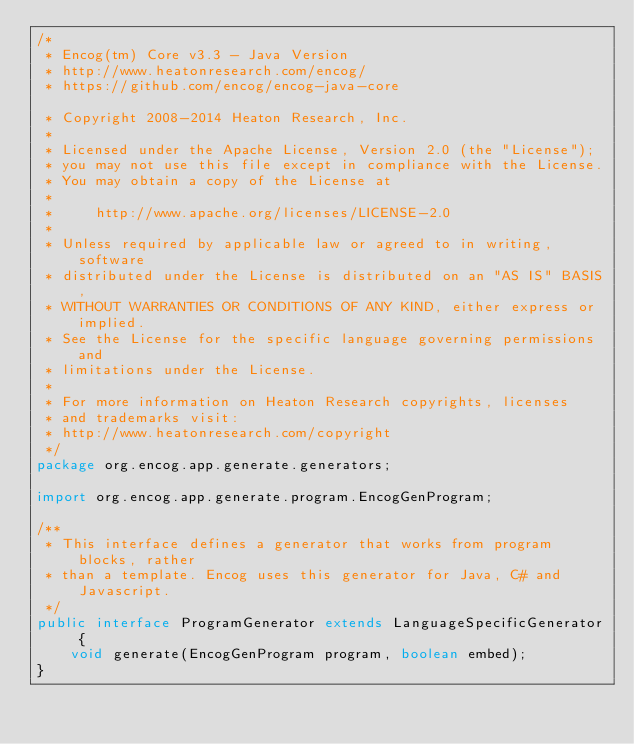Convert code to text. <code><loc_0><loc_0><loc_500><loc_500><_Java_>/*
 * Encog(tm) Core v3.3 - Java Version
 * http://www.heatonresearch.com/encog/
 * https://github.com/encog/encog-java-core
 
 * Copyright 2008-2014 Heaton Research, Inc.
 *
 * Licensed under the Apache License, Version 2.0 (the "License");
 * you may not use this file except in compliance with the License.
 * You may obtain a copy of the License at
 *
 *     http://www.apache.org/licenses/LICENSE-2.0
 *
 * Unless required by applicable law or agreed to in writing, software
 * distributed under the License is distributed on an "AS IS" BASIS,
 * WITHOUT WARRANTIES OR CONDITIONS OF ANY KIND, either express or implied.
 * See the License for the specific language governing permissions and
 * limitations under the License.
 *   
 * For more information on Heaton Research copyrights, licenses 
 * and trademarks visit:
 * http://www.heatonresearch.com/copyright
 */
package org.encog.app.generate.generators;

import org.encog.app.generate.program.EncogGenProgram;

/**
 * This interface defines a generator that works from program blocks, rather
 * than a template. Encog uses this generator for Java, C# and Javascript.
 */
public interface ProgramGenerator extends LanguageSpecificGenerator {
	void generate(EncogGenProgram program, boolean embed);
}
</code> 